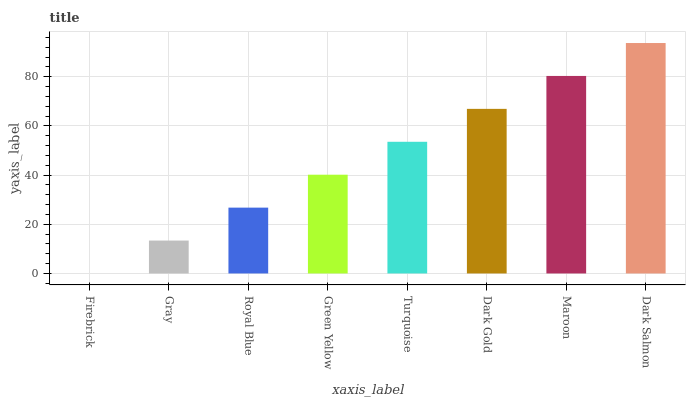Is Firebrick the minimum?
Answer yes or no. Yes. Is Dark Salmon the maximum?
Answer yes or no. Yes. Is Gray the minimum?
Answer yes or no. No. Is Gray the maximum?
Answer yes or no. No. Is Gray greater than Firebrick?
Answer yes or no. Yes. Is Firebrick less than Gray?
Answer yes or no. Yes. Is Firebrick greater than Gray?
Answer yes or no. No. Is Gray less than Firebrick?
Answer yes or no. No. Is Turquoise the high median?
Answer yes or no. Yes. Is Green Yellow the low median?
Answer yes or no. Yes. Is Firebrick the high median?
Answer yes or no. No. Is Dark Gold the low median?
Answer yes or no. No. 